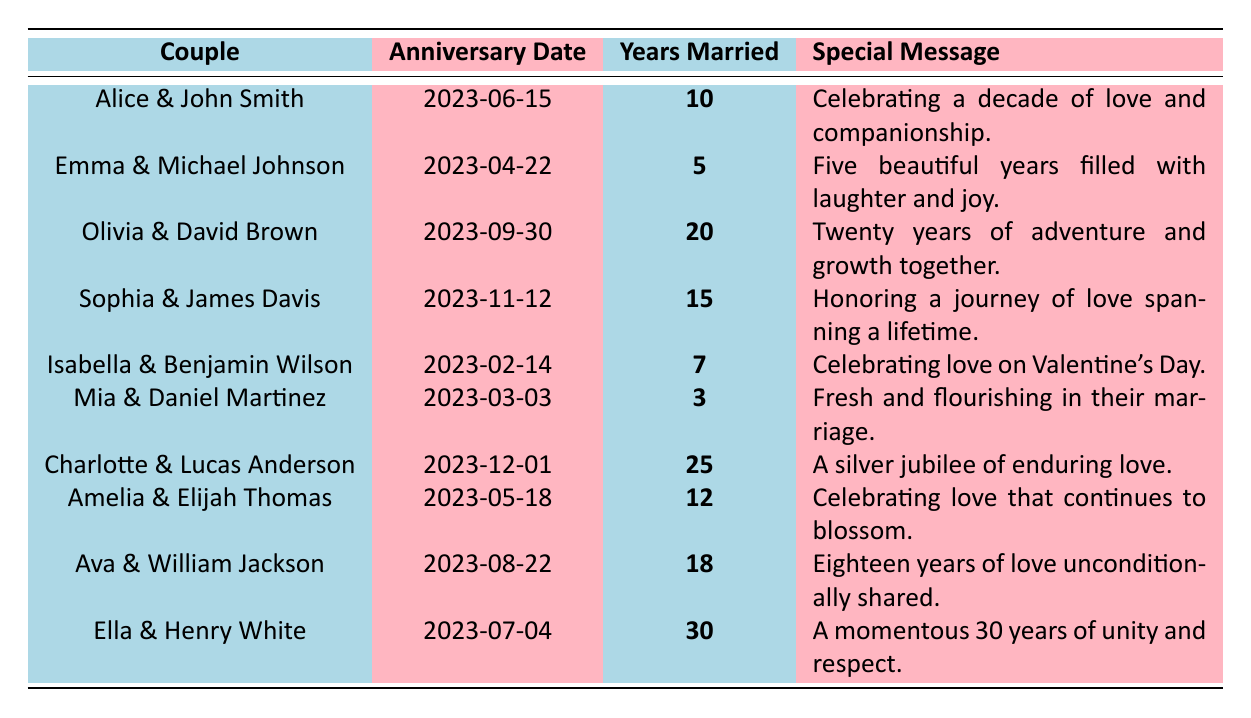What year anniversary are Alice and John Smith celebrating? The table lists Alice and John Smith with an anniversary date of 2023-06-15, and they have been married for 10 years. Thus, they are celebrating their 10th anniversary in 2023.
Answer: 10th anniversary Which couple has been married the longest? By examining the "Years Married" column, Ella and Henry White have been married for 30 years, which is the highest number in the table.
Answer: Ella and Henry White How many couples are celebrating an anniversary in the month of May? The table shows two entries for May: Amelia and Elijah Thomas on 2023-05-18, and no other entries for this month. Therefore, only one couple celebrates an anniversary in May.
Answer: 1 couple What is the average number of years married among the couples listed? Calculate the average by summing all years married (10 + 5 + 20 + 15 + 7 + 3 + 25 + 12 + 18 + 30 = 145) and dividing by the total number of couples (10): 145 / 10 = 14.5.
Answer: 14.5 years Are there any couples celebrating their anniversary on Valentine's Day? Looking at the anniversary dates, Isabella and Benjamin Wilson have their anniversary on "2023-02-14," which is Valentine's Day. Therefore, the answer is yes.
Answer: Yes Which couple is celebrating their silver jubilee? The term "silver jubilee" refers to 25 years of marriage. By checking the entries, Charlotte and Lucas Anderson have been married for 25 years, thus celebrating a silver jubilee.
Answer: Charlotte and Lucas Anderson How many couples have been married for more than 15 years? Review the "Years Married" column. Couples married for over 15 years are Olivia and David Brown (20), Ava and William Jackson (18), Ella and Henry White (30), and Charlotte and Lucas Anderson (25), totaling four couples.
Answer: 4 couples What special message is given for the couple married 18 years? The couple married for 18 years is Ava and William Jackson, and their special message is "Eighteen years of love unconditionally shared."
Answer: Eighteen years of love unconditionally shared Which couples have anniversary dates after September 2023? The table lists Sophia and James Davis (2023-11-12) and Charlotte and Lucas Anderson (2023-12-01) with dates after September. There are 2 couples with anniversary dates beyond September.
Answer: 2 couples What is the difference in years married between the couple celebrating 20 years and the couple celebrating 10 years? Olivia and David Brown are married for 20 years, while Alice and John Smith are married for 10 years. The difference is 20 - 10 = 10 years.
Answer: 10 years difference 